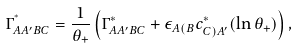<formula> <loc_0><loc_0><loc_500><loc_500>\Gamma ^ { ^ { * } } _ { A A ^ { \prime } B C } = \frac { 1 } { \theta _ { + } } \left ( \Gamma ^ { * } _ { A A ^ { \prime } B C } + \epsilon _ { A ( B } c ^ { * } _ { C ) A ^ { \prime } } ( \ln \theta _ { + } ) \right ) ,</formula> 